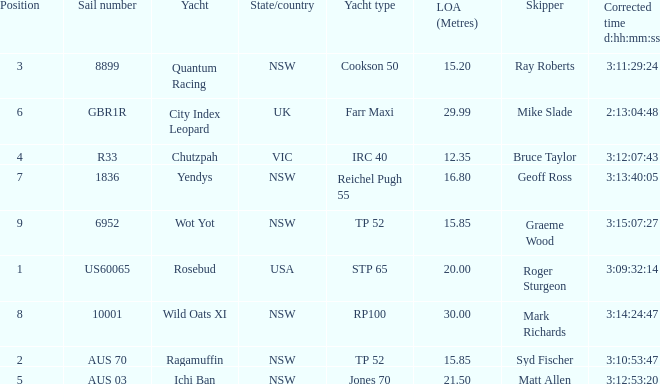What are all of the states or countries with a corrected time 3:13:40:05? NSW. 